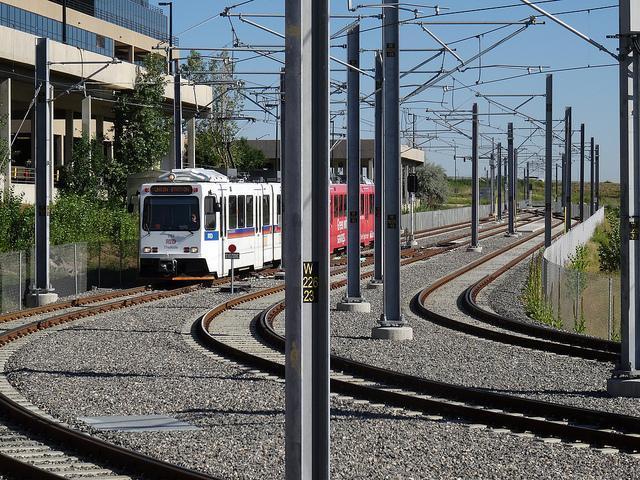How many sets of train tracks are here?
Give a very brief answer. 3. How many donuts have chocolate frosting?
Give a very brief answer. 0. 